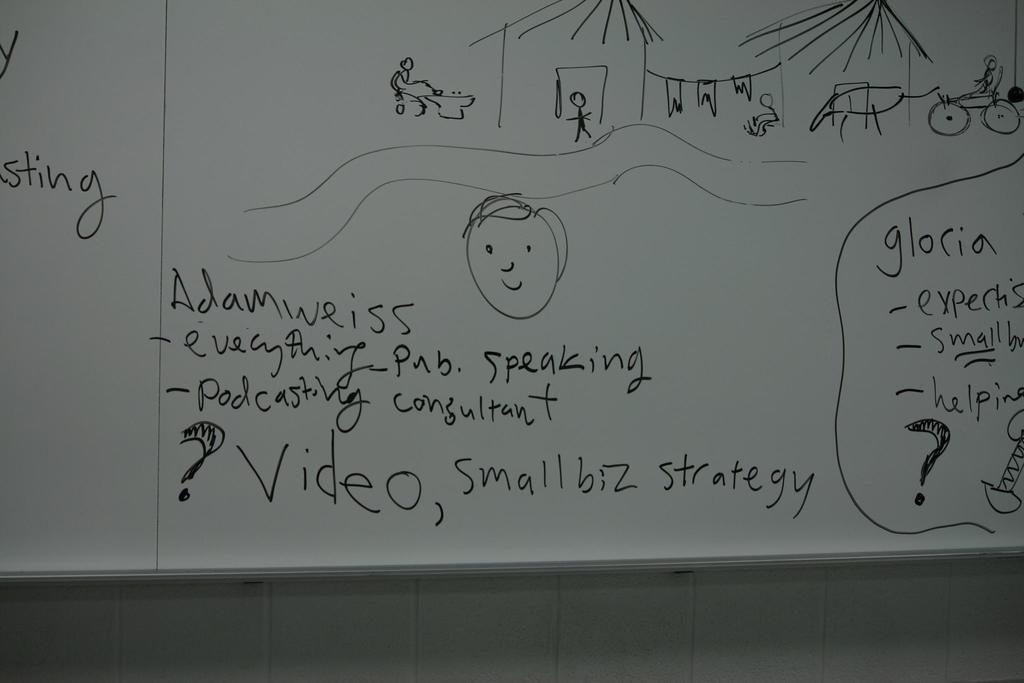<image>
Write a terse but informative summary of the picture. A whiteboard has a story about Gloria with pictures and a face drawn on it. 